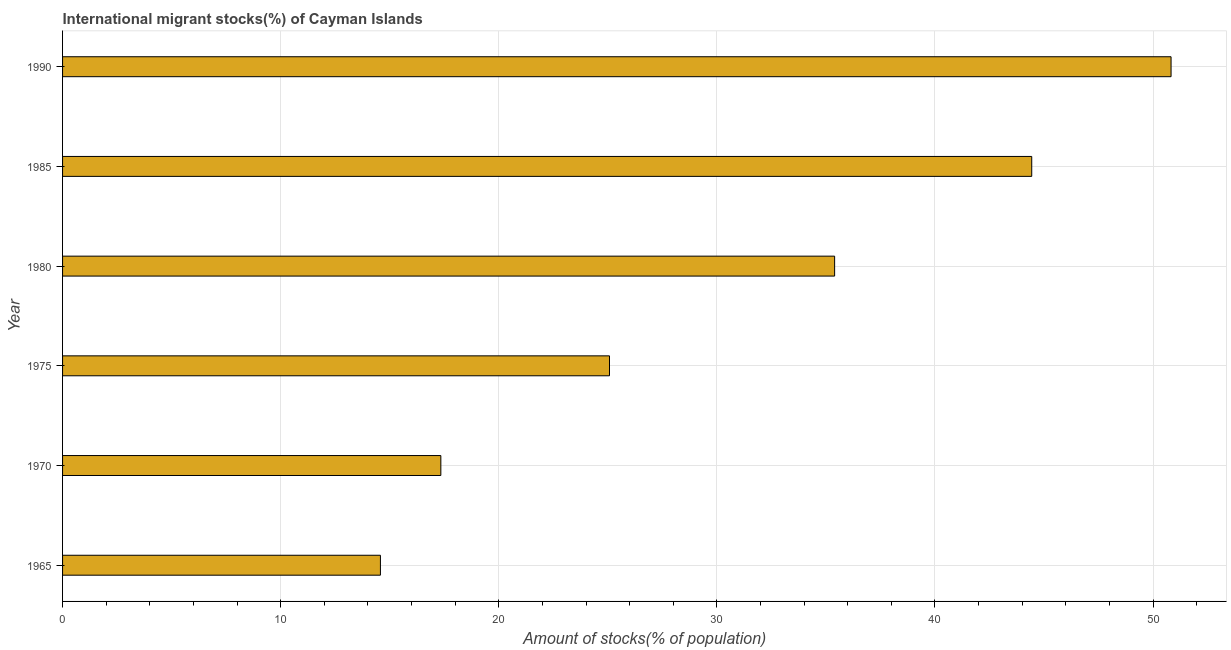Does the graph contain grids?
Your answer should be compact. Yes. What is the title of the graph?
Give a very brief answer. International migrant stocks(%) of Cayman Islands. What is the label or title of the X-axis?
Offer a very short reply. Amount of stocks(% of population). What is the number of international migrant stocks in 1980?
Offer a very short reply. 35.4. Across all years, what is the maximum number of international migrant stocks?
Offer a terse response. 50.83. Across all years, what is the minimum number of international migrant stocks?
Your answer should be very brief. 14.57. In which year was the number of international migrant stocks maximum?
Provide a short and direct response. 1990. In which year was the number of international migrant stocks minimum?
Provide a short and direct response. 1965. What is the sum of the number of international migrant stocks?
Provide a short and direct response. 187.66. What is the difference between the number of international migrant stocks in 1985 and 1990?
Your answer should be compact. -6.39. What is the average number of international migrant stocks per year?
Give a very brief answer. 31.28. What is the median number of international migrant stocks?
Offer a terse response. 30.24. Do a majority of the years between 1985 and 1980 (inclusive) have number of international migrant stocks greater than 50 %?
Provide a succinct answer. No. What is the ratio of the number of international migrant stocks in 1970 to that in 1985?
Make the answer very short. 0.39. What is the difference between the highest and the second highest number of international migrant stocks?
Provide a short and direct response. 6.39. Is the sum of the number of international migrant stocks in 1970 and 1990 greater than the maximum number of international migrant stocks across all years?
Offer a very short reply. Yes. What is the difference between the highest and the lowest number of international migrant stocks?
Offer a very short reply. 36.25. In how many years, is the number of international migrant stocks greater than the average number of international migrant stocks taken over all years?
Your answer should be very brief. 3. How many bars are there?
Provide a short and direct response. 6. Are the values on the major ticks of X-axis written in scientific E-notation?
Make the answer very short. No. What is the Amount of stocks(% of population) in 1965?
Your response must be concise. 14.57. What is the Amount of stocks(% of population) in 1970?
Give a very brief answer. 17.34. What is the Amount of stocks(% of population) of 1975?
Provide a short and direct response. 25.08. What is the Amount of stocks(% of population) of 1980?
Offer a very short reply. 35.4. What is the Amount of stocks(% of population) in 1985?
Provide a succinct answer. 44.44. What is the Amount of stocks(% of population) in 1990?
Give a very brief answer. 50.83. What is the difference between the Amount of stocks(% of population) in 1965 and 1970?
Provide a short and direct response. -2.77. What is the difference between the Amount of stocks(% of population) in 1965 and 1975?
Offer a terse response. -10.5. What is the difference between the Amount of stocks(% of population) in 1965 and 1980?
Your response must be concise. -20.83. What is the difference between the Amount of stocks(% of population) in 1965 and 1985?
Provide a succinct answer. -29.86. What is the difference between the Amount of stocks(% of population) in 1965 and 1990?
Provide a short and direct response. -36.25. What is the difference between the Amount of stocks(% of population) in 1970 and 1975?
Offer a terse response. -7.73. What is the difference between the Amount of stocks(% of population) in 1970 and 1980?
Offer a very short reply. -18.05. What is the difference between the Amount of stocks(% of population) in 1970 and 1985?
Your response must be concise. -27.09. What is the difference between the Amount of stocks(% of population) in 1970 and 1990?
Offer a very short reply. -33.48. What is the difference between the Amount of stocks(% of population) in 1975 and 1980?
Offer a very short reply. -10.32. What is the difference between the Amount of stocks(% of population) in 1975 and 1985?
Ensure brevity in your answer.  -19.36. What is the difference between the Amount of stocks(% of population) in 1975 and 1990?
Ensure brevity in your answer.  -25.75. What is the difference between the Amount of stocks(% of population) in 1980 and 1985?
Your answer should be compact. -9.04. What is the difference between the Amount of stocks(% of population) in 1980 and 1990?
Ensure brevity in your answer.  -15.43. What is the difference between the Amount of stocks(% of population) in 1985 and 1990?
Offer a terse response. -6.39. What is the ratio of the Amount of stocks(% of population) in 1965 to that in 1970?
Your answer should be compact. 0.84. What is the ratio of the Amount of stocks(% of population) in 1965 to that in 1975?
Your answer should be very brief. 0.58. What is the ratio of the Amount of stocks(% of population) in 1965 to that in 1980?
Your response must be concise. 0.41. What is the ratio of the Amount of stocks(% of population) in 1965 to that in 1985?
Your answer should be compact. 0.33. What is the ratio of the Amount of stocks(% of population) in 1965 to that in 1990?
Give a very brief answer. 0.29. What is the ratio of the Amount of stocks(% of population) in 1970 to that in 1975?
Provide a succinct answer. 0.69. What is the ratio of the Amount of stocks(% of population) in 1970 to that in 1980?
Your answer should be compact. 0.49. What is the ratio of the Amount of stocks(% of population) in 1970 to that in 1985?
Make the answer very short. 0.39. What is the ratio of the Amount of stocks(% of population) in 1970 to that in 1990?
Provide a succinct answer. 0.34. What is the ratio of the Amount of stocks(% of population) in 1975 to that in 1980?
Give a very brief answer. 0.71. What is the ratio of the Amount of stocks(% of population) in 1975 to that in 1985?
Give a very brief answer. 0.56. What is the ratio of the Amount of stocks(% of population) in 1975 to that in 1990?
Give a very brief answer. 0.49. What is the ratio of the Amount of stocks(% of population) in 1980 to that in 1985?
Offer a terse response. 0.8. What is the ratio of the Amount of stocks(% of population) in 1980 to that in 1990?
Provide a succinct answer. 0.7. What is the ratio of the Amount of stocks(% of population) in 1985 to that in 1990?
Your response must be concise. 0.87. 